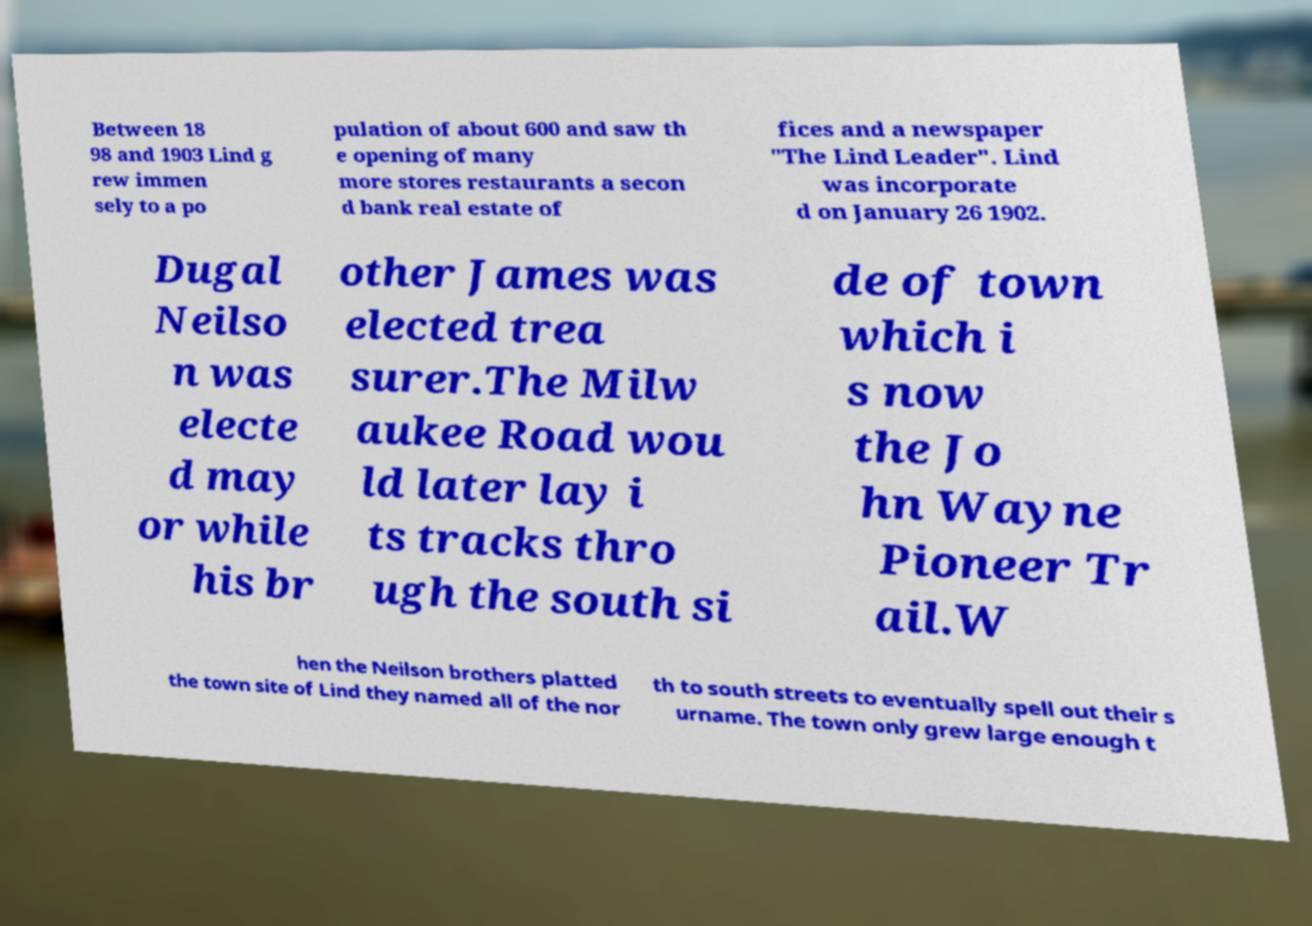Can you read and provide the text displayed in the image?This photo seems to have some interesting text. Can you extract and type it out for me? Between 18 98 and 1903 Lind g rew immen sely to a po pulation of about 600 and saw th e opening of many more stores restaurants a secon d bank real estate of fices and a newspaper "The Lind Leader". Lind was incorporate d on January 26 1902. Dugal Neilso n was electe d may or while his br other James was elected trea surer.The Milw aukee Road wou ld later lay i ts tracks thro ugh the south si de of town which i s now the Jo hn Wayne Pioneer Tr ail.W hen the Neilson brothers platted the town site of Lind they named all of the nor th to south streets to eventually spell out their s urname. The town only grew large enough t 